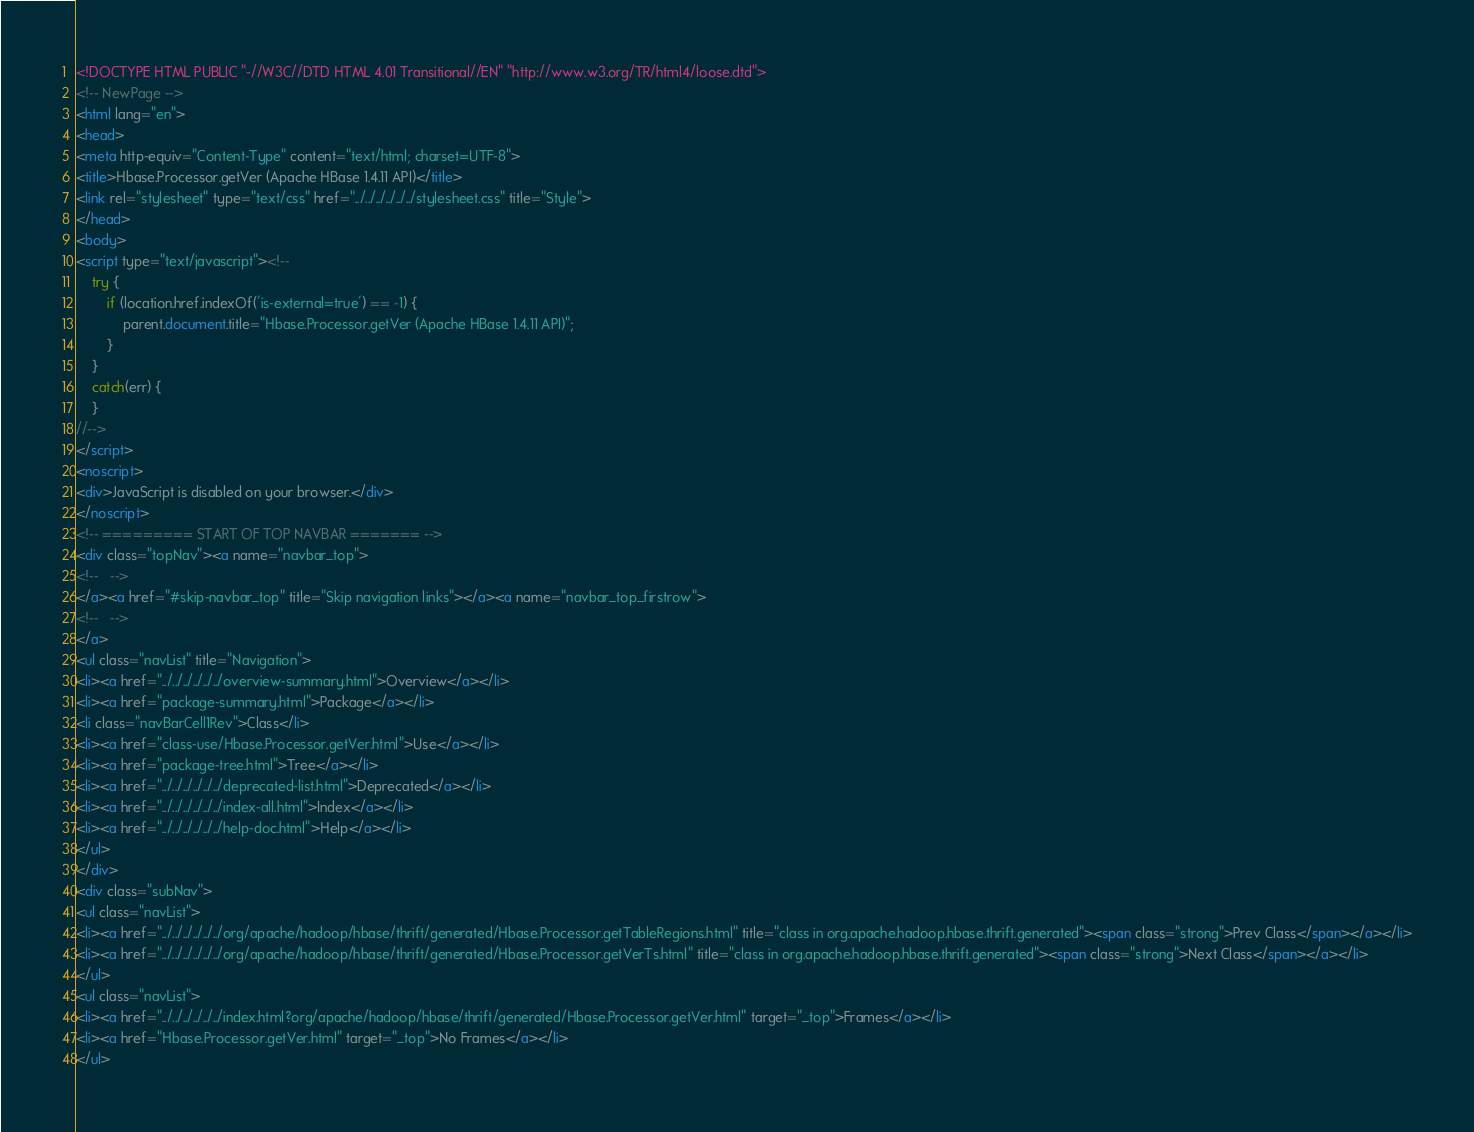Convert code to text. <code><loc_0><loc_0><loc_500><loc_500><_HTML_><!DOCTYPE HTML PUBLIC "-//W3C//DTD HTML 4.01 Transitional//EN" "http://www.w3.org/TR/html4/loose.dtd">
<!-- NewPage -->
<html lang="en">
<head>
<meta http-equiv="Content-Type" content="text/html; charset=UTF-8">
<title>Hbase.Processor.getVer (Apache HBase 1.4.11 API)</title>
<link rel="stylesheet" type="text/css" href="../../../../../../stylesheet.css" title="Style">
</head>
<body>
<script type="text/javascript"><!--
    try {
        if (location.href.indexOf('is-external=true') == -1) {
            parent.document.title="Hbase.Processor.getVer (Apache HBase 1.4.11 API)";
        }
    }
    catch(err) {
    }
//-->
</script>
<noscript>
<div>JavaScript is disabled on your browser.</div>
</noscript>
<!-- ========= START OF TOP NAVBAR ======= -->
<div class="topNav"><a name="navbar_top">
<!--   -->
</a><a href="#skip-navbar_top" title="Skip navigation links"></a><a name="navbar_top_firstrow">
<!--   -->
</a>
<ul class="navList" title="Navigation">
<li><a href="../../../../../../overview-summary.html">Overview</a></li>
<li><a href="package-summary.html">Package</a></li>
<li class="navBarCell1Rev">Class</li>
<li><a href="class-use/Hbase.Processor.getVer.html">Use</a></li>
<li><a href="package-tree.html">Tree</a></li>
<li><a href="../../../../../../deprecated-list.html">Deprecated</a></li>
<li><a href="../../../../../../index-all.html">Index</a></li>
<li><a href="../../../../../../help-doc.html">Help</a></li>
</ul>
</div>
<div class="subNav">
<ul class="navList">
<li><a href="../../../../../../org/apache/hadoop/hbase/thrift/generated/Hbase.Processor.getTableRegions.html" title="class in org.apache.hadoop.hbase.thrift.generated"><span class="strong">Prev Class</span></a></li>
<li><a href="../../../../../../org/apache/hadoop/hbase/thrift/generated/Hbase.Processor.getVerTs.html" title="class in org.apache.hadoop.hbase.thrift.generated"><span class="strong">Next Class</span></a></li>
</ul>
<ul class="navList">
<li><a href="../../../../../../index.html?org/apache/hadoop/hbase/thrift/generated/Hbase.Processor.getVer.html" target="_top">Frames</a></li>
<li><a href="Hbase.Processor.getVer.html" target="_top">No Frames</a></li>
</ul></code> 